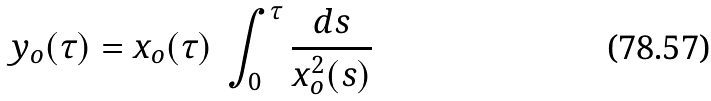<formula> <loc_0><loc_0><loc_500><loc_500>y _ { o } ( \tau ) = x _ { o } ( \tau ) \ \int _ { 0 } ^ { \tau } { \frac { d s } { x _ { o } ^ { 2 } ( s ) } }</formula> 